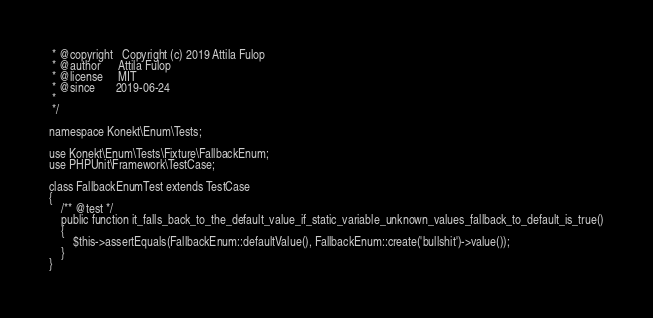Convert code to text. <code><loc_0><loc_0><loc_500><loc_500><_PHP_> * @copyright   Copyright (c) 2019 Attila Fulop
 * @author      Attila Fulop
 * @license     MIT
 * @since       2019-06-24
 *
 */

namespace Konekt\Enum\Tests;

use Konekt\Enum\Tests\Fixture\FallbackEnum;
use PHPUnit\Framework\TestCase;

class FallbackEnumTest extends TestCase
{
    /** @test */
    public function it_falls_back_to_the_default_value_if_static_variable_unknown_values_fallback_to_default_is_true()
    {
        $this->assertEquals(FallbackEnum::defaultValue(), FallbackEnum::create('bullshit')->value());
    }
}
</code> 